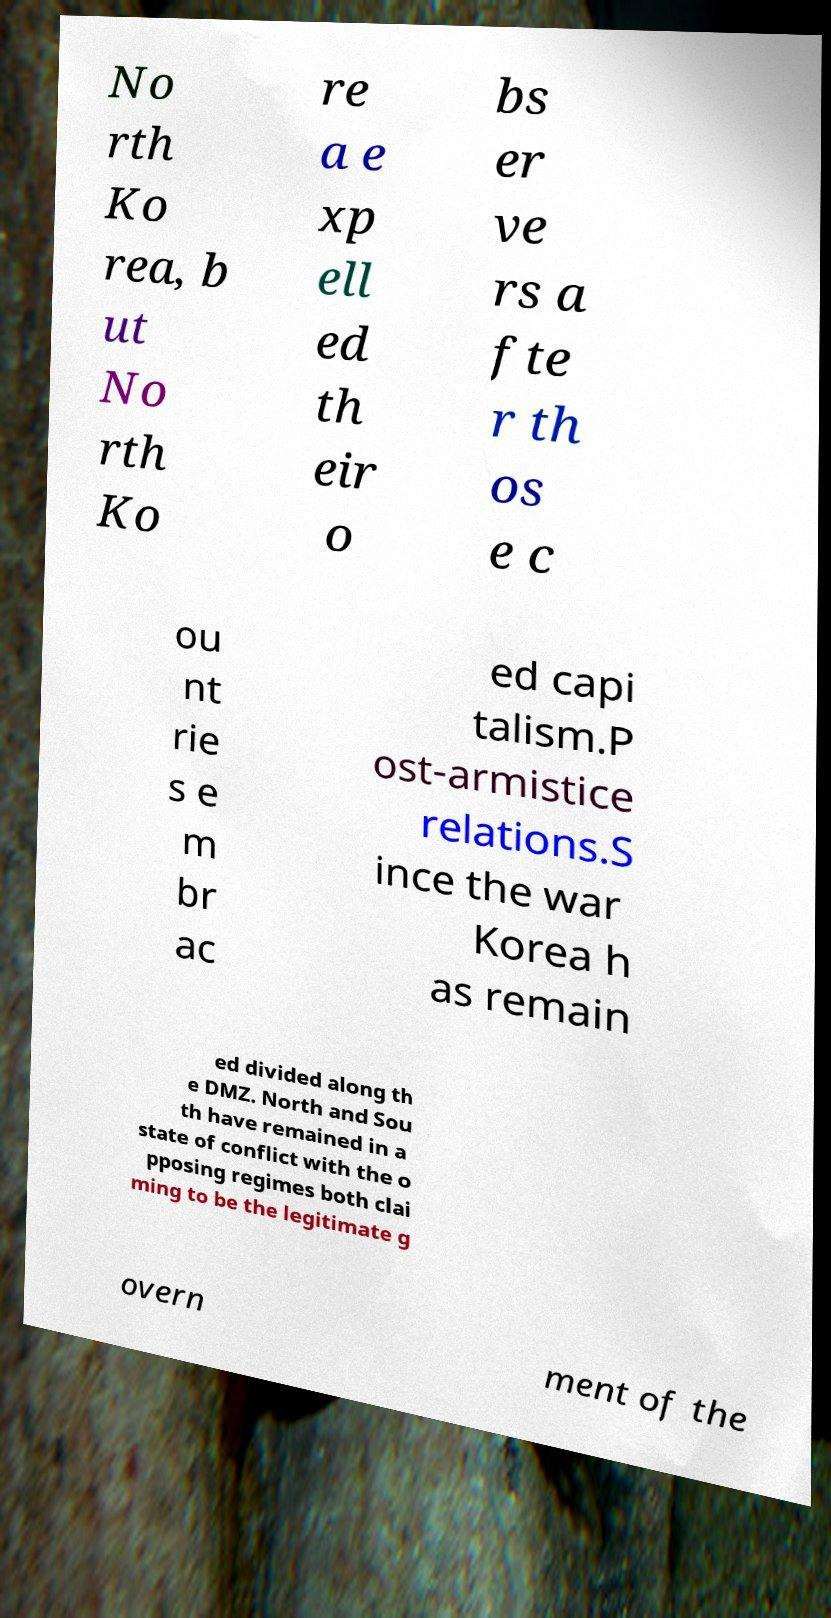Please identify and transcribe the text found in this image. No rth Ko rea, b ut No rth Ko re a e xp ell ed th eir o bs er ve rs a fte r th os e c ou nt rie s e m br ac ed capi talism.P ost-armistice relations.S ince the war Korea h as remain ed divided along th e DMZ. North and Sou th have remained in a state of conflict with the o pposing regimes both clai ming to be the legitimate g overn ment of the 